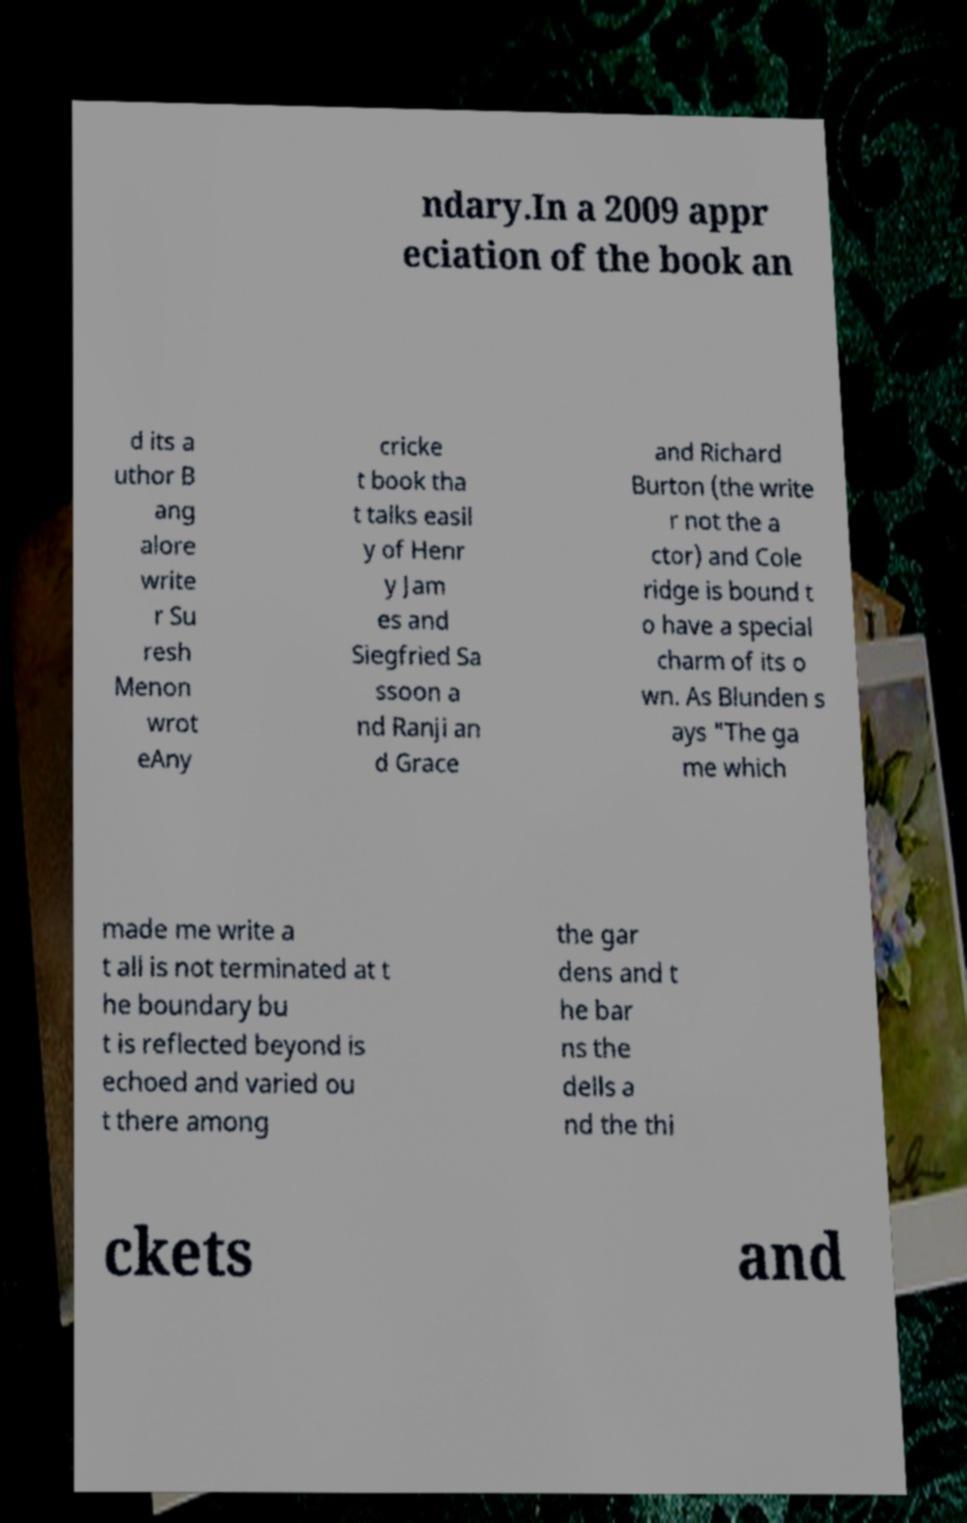I need the written content from this picture converted into text. Can you do that? ndary.In a 2009 appr eciation of the book an d its a uthor B ang alore write r Su resh Menon wrot eAny cricke t book tha t talks easil y of Henr y Jam es and Siegfried Sa ssoon a nd Ranji an d Grace and Richard Burton (the write r not the a ctor) and Cole ridge is bound t o have a special charm of its o wn. As Blunden s ays "The ga me which made me write a t all is not terminated at t he boundary bu t is reflected beyond is echoed and varied ou t there among the gar dens and t he bar ns the dells a nd the thi ckets and 